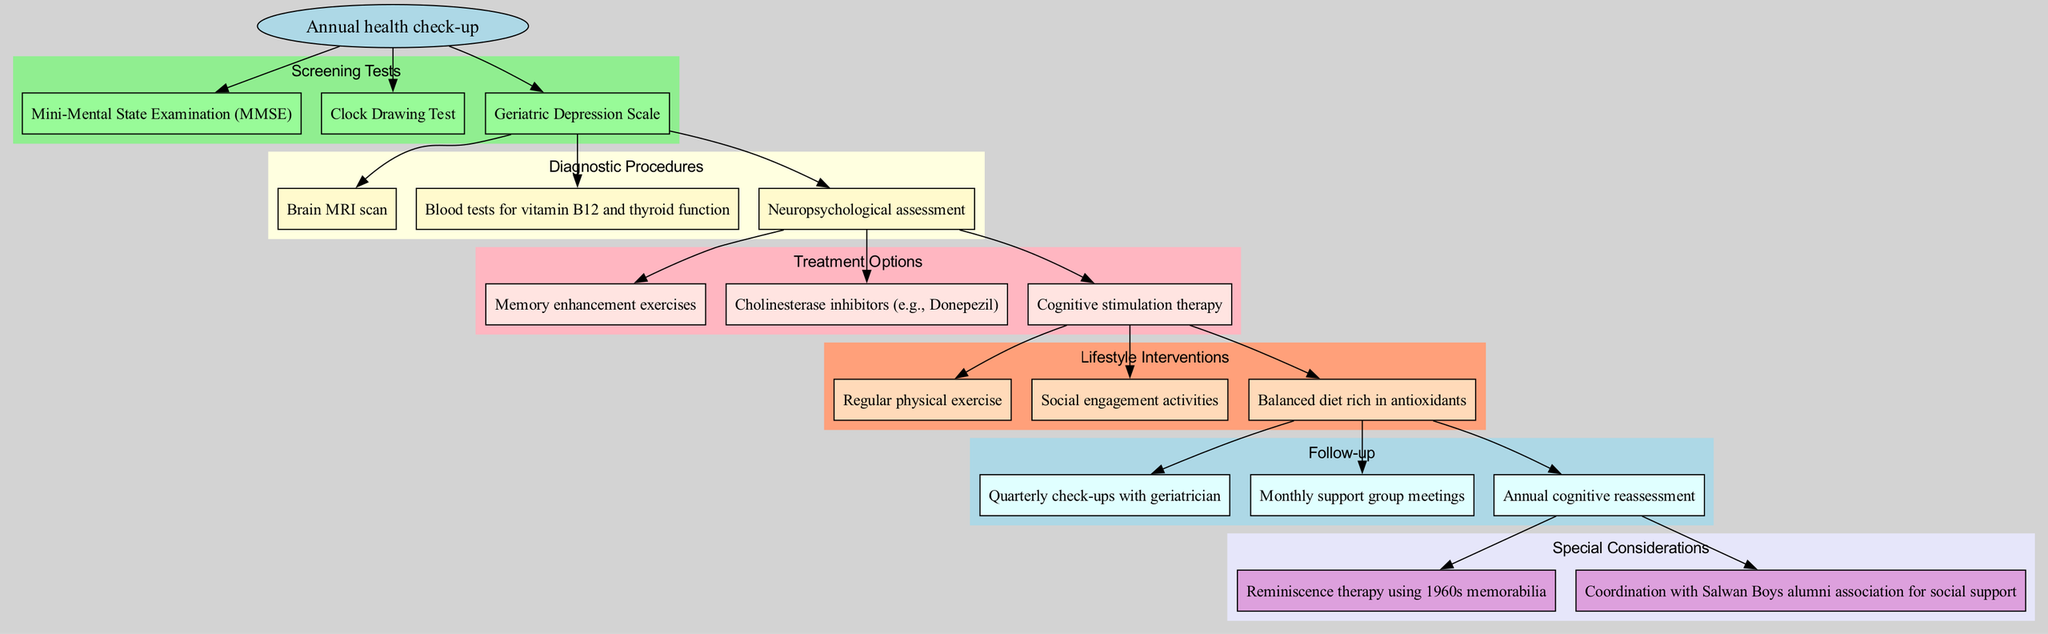What is the starting point of the clinical pathway? The starting point is explicitly mentioned in the diagram as the "Annual health check-up." No other nodes lead from this point, making it the first element to consider.
Answer: Annual health check-up How many screening tests are listed in the diagram? The diagram displays three screening tests as nodes under the "Screening Tests" category. Since these nodes directly represent tests, we can count them easily to find the total.
Answer: 3 Which diagnostic procedure involves scanning the brain? The "Brain MRI scan" is explicitly labeled in the diagram as a diagnostic procedure associated with the secondary flow following the screening tests.
Answer: Brain MRI scan What is the last treatment option mentioned? Reviewing the diagram, we can locate the "Treatment Options" section where the last treatment listed is "Cognitive stimulation therapy." Being the last node in the section, it is easy to identify.
Answer: Cognitive stimulation therapy Which lifestyle intervention is related to social activities? The "Social engagement activities" node under the "Lifestyle Interventions" category refers explicitly to activities that foster social engagement, making it the answer.
Answer: Social engagement activities What is the follow-up frequency suggested in the clinical pathway? The "Follow-up" section in the diagram lists several follow-up methods, but the context implies regularity. Specifically, "Quarterly check-ups with geriatrician" indicates a quarterly frequency.
Answer: Quarterly What encompasses special considerations related to the educational background? The diagram highlights "Reminiscence therapy using 1960s memorabilia" as a special consideration, connecting the participants’ educational memories to therapy. This specific mention implies a educational background tying into treatment.
Answer: Reminiscence therapy using 1960s memorabilia What links the follow-up process to special considerations? In the diagram, the edge connecting the last follow-up node leads to special considerations, indicating a direct relationship between follow-up and special recommendations such as the coordination with alumni.
Answer: Coordination with Salwan Boys alumni association for social support 